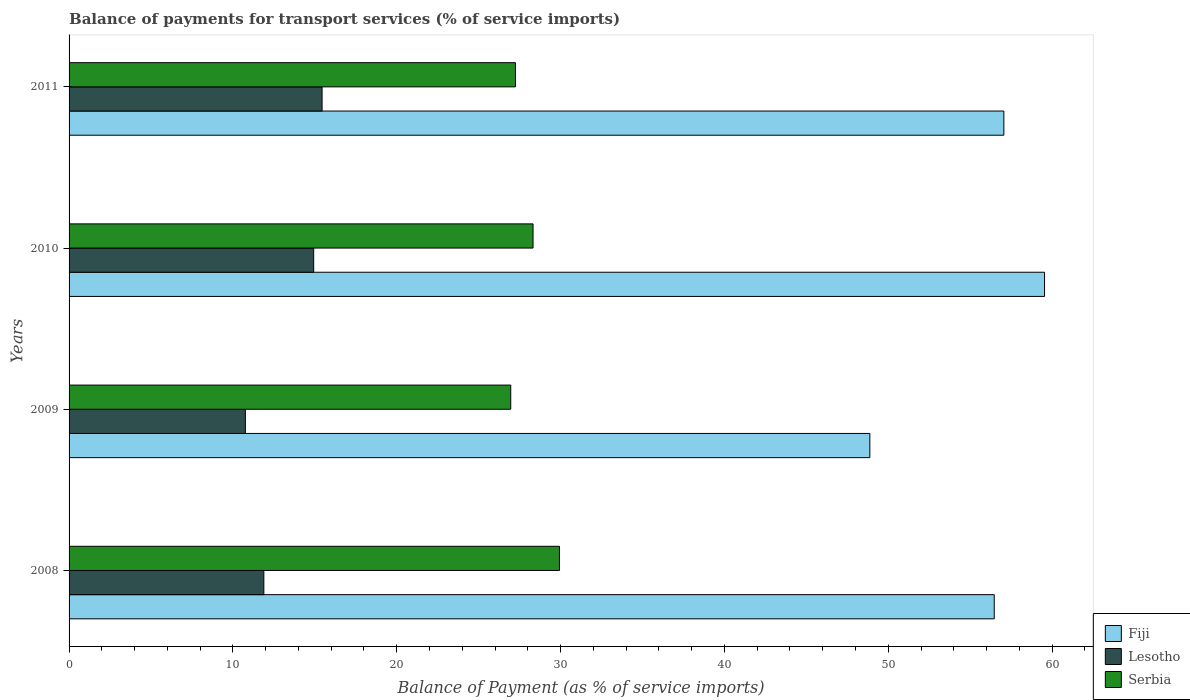Are the number of bars on each tick of the Y-axis equal?
Your response must be concise. Yes. What is the label of the 4th group of bars from the top?
Offer a very short reply. 2008. What is the balance of payments for transport services in Fiji in 2010?
Keep it short and to the point. 59.54. Across all years, what is the maximum balance of payments for transport services in Lesotho?
Give a very brief answer. 15.44. Across all years, what is the minimum balance of payments for transport services in Lesotho?
Offer a very short reply. 10.76. In which year was the balance of payments for transport services in Serbia maximum?
Provide a short and direct response. 2008. What is the total balance of payments for transport services in Fiji in the graph?
Your answer should be very brief. 221.94. What is the difference between the balance of payments for transport services in Serbia in 2010 and that in 2011?
Provide a short and direct response. 1.07. What is the difference between the balance of payments for transport services in Serbia in 2010 and the balance of payments for transport services in Lesotho in 2009?
Ensure brevity in your answer.  17.56. What is the average balance of payments for transport services in Fiji per year?
Your response must be concise. 55.48. In the year 2010, what is the difference between the balance of payments for transport services in Fiji and balance of payments for transport services in Lesotho?
Your response must be concise. 44.61. In how many years, is the balance of payments for transport services in Serbia greater than 30 %?
Offer a terse response. 0. What is the ratio of the balance of payments for transport services in Serbia in 2010 to that in 2011?
Offer a terse response. 1.04. Is the difference between the balance of payments for transport services in Fiji in 2008 and 2011 greater than the difference between the balance of payments for transport services in Lesotho in 2008 and 2011?
Ensure brevity in your answer.  Yes. What is the difference between the highest and the second highest balance of payments for transport services in Serbia?
Make the answer very short. 1.61. What is the difference between the highest and the lowest balance of payments for transport services in Fiji?
Provide a short and direct response. 10.66. In how many years, is the balance of payments for transport services in Lesotho greater than the average balance of payments for transport services in Lesotho taken over all years?
Your response must be concise. 2. Is the sum of the balance of payments for transport services in Fiji in 2008 and 2011 greater than the maximum balance of payments for transport services in Lesotho across all years?
Offer a terse response. Yes. What does the 1st bar from the top in 2009 represents?
Your response must be concise. Serbia. What does the 3rd bar from the bottom in 2011 represents?
Make the answer very short. Serbia. Is it the case that in every year, the sum of the balance of payments for transport services in Serbia and balance of payments for transport services in Fiji is greater than the balance of payments for transport services in Lesotho?
Ensure brevity in your answer.  Yes. Are all the bars in the graph horizontal?
Keep it short and to the point. Yes. How many years are there in the graph?
Offer a terse response. 4. Are the values on the major ticks of X-axis written in scientific E-notation?
Ensure brevity in your answer.  No. Does the graph contain grids?
Offer a very short reply. No. Where does the legend appear in the graph?
Provide a short and direct response. Bottom right. What is the title of the graph?
Offer a terse response. Balance of payments for transport services (% of service imports). What is the label or title of the X-axis?
Ensure brevity in your answer.  Balance of Payment (as % of service imports). What is the label or title of the Y-axis?
Provide a short and direct response. Years. What is the Balance of Payment (as % of service imports) of Fiji in 2008?
Give a very brief answer. 56.47. What is the Balance of Payment (as % of service imports) of Lesotho in 2008?
Provide a succinct answer. 11.89. What is the Balance of Payment (as % of service imports) in Serbia in 2008?
Your response must be concise. 29.93. What is the Balance of Payment (as % of service imports) of Fiji in 2009?
Offer a terse response. 48.87. What is the Balance of Payment (as % of service imports) in Lesotho in 2009?
Offer a very short reply. 10.76. What is the Balance of Payment (as % of service imports) of Serbia in 2009?
Give a very brief answer. 26.96. What is the Balance of Payment (as % of service imports) in Fiji in 2010?
Your response must be concise. 59.54. What is the Balance of Payment (as % of service imports) in Lesotho in 2010?
Provide a short and direct response. 14.93. What is the Balance of Payment (as % of service imports) of Serbia in 2010?
Your response must be concise. 28.32. What is the Balance of Payment (as % of service imports) in Fiji in 2011?
Make the answer very short. 57.06. What is the Balance of Payment (as % of service imports) of Lesotho in 2011?
Your answer should be compact. 15.44. What is the Balance of Payment (as % of service imports) in Serbia in 2011?
Your response must be concise. 27.25. Across all years, what is the maximum Balance of Payment (as % of service imports) in Fiji?
Make the answer very short. 59.54. Across all years, what is the maximum Balance of Payment (as % of service imports) in Lesotho?
Your answer should be compact. 15.44. Across all years, what is the maximum Balance of Payment (as % of service imports) in Serbia?
Provide a short and direct response. 29.93. Across all years, what is the minimum Balance of Payment (as % of service imports) in Fiji?
Keep it short and to the point. 48.87. Across all years, what is the minimum Balance of Payment (as % of service imports) in Lesotho?
Make the answer very short. 10.76. Across all years, what is the minimum Balance of Payment (as % of service imports) of Serbia?
Make the answer very short. 26.96. What is the total Balance of Payment (as % of service imports) in Fiji in the graph?
Give a very brief answer. 221.94. What is the total Balance of Payment (as % of service imports) of Lesotho in the graph?
Make the answer very short. 53.02. What is the total Balance of Payment (as % of service imports) of Serbia in the graph?
Make the answer very short. 112.45. What is the difference between the Balance of Payment (as % of service imports) in Fiji in 2008 and that in 2009?
Ensure brevity in your answer.  7.59. What is the difference between the Balance of Payment (as % of service imports) in Lesotho in 2008 and that in 2009?
Your answer should be compact. 1.13. What is the difference between the Balance of Payment (as % of service imports) of Serbia in 2008 and that in 2009?
Your answer should be very brief. 2.98. What is the difference between the Balance of Payment (as % of service imports) in Fiji in 2008 and that in 2010?
Offer a very short reply. -3.07. What is the difference between the Balance of Payment (as % of service imports) of Lesotho in 2008 and that in 2010?
Your answer should be compact. -3.04. What is the difference between the Balance of Payment (as % of service imports) of Serbia in 2008 and that in 2010?
Give a very brief answer. 1.61. What is the difference between the Balance of Payment (as % of service imports) of Fiji in 2008 and that in 2011?
Provide a short and direct response. -0.59. What is the difference between the Balance of Payment (as % of service imports) of Lesotho in 2008 and that in 2011?
Your answer should be compact. -3.55. What is the difference between the Balance of Payment (as % of service imports) of Serbia in 2008 and that in 2011?
Keep it short and to the point. 2.69. What is the difference between the Balance of Payment (as % of service imports) of Fiji in 2009 and that in 2010?
Offer a terse response. -10.66. What is the difference between the Balance of Payment (as % of service imports) of Lesotho in 2009 and that in 2010?
Offer a terse response. -4.17. What is the difference between the Balance of Payment (as % of service imports) in Serbia in 2009 and that in 2010?
Give a very brief answer. -1.36. What is the difference between the Balance of Payment (as % of service imports) of Fiji in 2009 and that in 2011?
Your answer should be very brief. -8.18. What is the difference between the Balance of Payment (as % of service imports) in Lesotho in 2009 and that in 2011?
Your answer should be very brief. -4.68. What is the difference between the Balance of Payment (as % of service imports) of Serbia in 2009 and that in 2011?
Your answer should be compact. -0.29. What is the difference between the Balance of Payment (as % of service imports) of Fiji in 2010 and that in 2011?
Provide a succinct answer. 2.48. What is the difference between the Balance of Payment (as % of service imports) in Lesotho in 2010 and that in 2011?
Give a very brief answer. -0.51. What is the difference between the Balance of Payment (as % of service imports) in Serbia in 2010 and that in 2011?
Your response must be concise. 1.07. What is the difference between the Balance of Payment (as % of service imports) of Fiji in 2008 and the Balance of Payment (as % of service imports) of Lesotho in 2009?
Offer a terse response. 45.71. What is the difference between the Balance of Payment (as % of service imports) in Fiji in 2008 and the Balance of Payment (as % of service imports) in Serbia in 2009?
Offer a very short reply. 29.51. What is the difference between the Balance of Payment (as % of service imports) in Lesotho in 2008 and the Balance of Payment (as % of service imports) in Serbia in 2009?
Give a very brief answer. -15.07. What is the difference between the Balance of Payment (as % of service imports) in Fiji in 2008 and the Balance of Payment (as % of service imports) in Lesotho in 2010?
Your answer should be very brief. 41.54. What is the difference between the Balance of Payment (as % of service imports) in Fiji in 2008 and the Balance of Payment (as % of service imports) in Serbia in 2010?
Make the answer very short. 28.15. What is the difference between the Balance of Payment (as % of service imports) of Lesotho in 2008 and the Balance of Payment (as % of service imports) of Serbia in 2010?
Your answer should be compact. -16.43. What is the difference between the Balance of Payment (as % of service imports) in Fiji in 2008 and the Balance of Payment (as % of service imports) in Lesotho in 2011?
Your response must be concise. 41.03. What is the difference between the Balance of Payment (as % of service imports) of Fiji in 2008 and the Balance of Payment (as % of service imports) of Serbia in 2011?
Keep it short and to the point. 29.22. What is the difference between the Balance of Payment (as % of service imports) in Lesotho in 2008 and the Balance of Payment (as % of service imports) in Serbia in 2011?
Offer a terse response. -15.36. What is the difference between the Balance of Payment (as % of service imports) of Fiji in 2009 and the Balance of Payment (as % of service imports) of Lesotho in 2010?
Make the answer very short. 33.95. What is the difference between the Balance of Payment (as % of service imports) of Fiji in 2009 and the Balance of Payment (as % of service imports) of Serbia in 2010?
Provide a succinct answer. 20.56. What is the difference between the Balance of Payment (as % of service imports) in Lesotho in 2009 and the Balance of Payment (as % of service imports) in Serbia in 2010?
Keep it short and to the point. -17.56. What is the difference between the Balance of Payment (as % of service imports) of Fiji in 2009 and the Balance of Payment (as % of service imports) of Lesotho in 2011?
Provide a succinct answer. 33.43. What is the difference between the Balance of Payment (as % of service imports) in Fiji in 2009 and the Balance of Payment (as % of service imports) in Serbia in 2011?
Your answer should be very brief. 21.63. What is the difference between the Balance of Payment (as % of service imports) of Lesotho in 2009 and the Balance of Payment (as % of service imports) of Serbia in 2011?
Provide a short and direct response. -16.48. What is the difference between the Balance of Payment (as % of service imports) in Fiji in 2010 and the Balance of Payment (as % of service imports) in Lesotho in 2011?
Your response must be concise. 44.1. What is the difference between the Balance of Payment (as % of service imports) in Fiji in 2010 and the Balance of Payment (as % of service imports) in Serbia in 2011?
Give a very brief answer. 32.29. What is the difference between the Balance of Payment (as % of service imports) in Lesotho in 2010 and the Balance of Payment (as % of service imports) in Serbia in 2011?
Provide a succinct answer. -12.32. What is the average Balance of Payment (as % of service imports) of Fiji per year?
Your answer should be very brief. 55.48. What is the average Balance of Payment (as % of service imports) of Lesotho per year?
Your response must be concise. 13.26. What is the average Balance of Payment (as % of service imports) in Serbia per year?
Your response must be concise. 28.11. In the year 2008, what is the difference between the Balance of Payment (as % of service imports) in Fiji and Balance of Payment (as % of service imports) in Lesotho?
Provide a succinct answer. 44.58. In the year 2008, what is the difference between the Balance of Payment (as % of service imports) of Fiji and Balance of Payment (as % of service imports) of Serbia?
Make the answer very short. 26.54. In the year 2008, what is the difference between the Balance of Payment (as % of service imports) of Lesotho and Balance of Payment (as % of service imports) of Serbia?
Give a very brief answer. -18.04. In the year 2009, what is the difference between the Balance of Payment (as % of service imports) in Fiji and Balance of Payment (as % of service imports) in Lesotho?
Your answer should be compact. 38.11. In the year 2009, what is the difference between the Balance of Payment (as % of service imports) of Fiji and Balance of Payment (as % of service imports) of Serbia?
Keep it short and to the point. 21.92. In the year 2009, what is the difference between the Balance of Payment (as % of service imports) in Lesotho and Balance of Payment (as % of service imports) in Serbia?
Offer a terse response. -16.2. In the year 2010, what is the difference between the Balance of Payment (as % of service imports) in Fiji and Balance of Payment (as % of service imports) in Lesotho?
Offer a very short reply. 44.61. In the year 2010, what is the difference between the Balance of Payment (as % of service imports) of Fiji and Balance of Payment (as % of service imports) of Serbia?
Your response must be concise. 31.22. In the year 2010, what is the difference between the Balance of Payment (as % of service imports) of Lesotho and Balance of Payment (as % of service imports) of Serbia?
Offer a terse response. -13.39. In the year 2011, what is the difference between the Balance of Payment (as % of service imports) of Fiji and Balance of Payment (as % of service imports) of Lesotho?
Your answer should be very brief. 41.61. In the year 2011, what is the difference between the Balance of Payment (as % of service imports) of Fiji and Balance of Payment (as % of service imports) of Serbia?
Your response must be concise. 29.81. In the year 2011, what is the difference between the Balance of Payment (as % of service imports) in Lesotho and Balance of Payment (as % of service imports) in Serbia?
Provide a succinct answer. -11.8. What is the ratio of the Balance of Payment (as % of service imports) of Fiji in 2008 to that in 2009?
Give a very brief answer. 1.16. What is the ratio of the Balance of Payment (as % of service imports) in Lesotho in 2008 to that in 2009?
Keep it short and to the point. 1.1. What is the ratio of the Balance of Payment (as % of service imports) in Serbia in 2008 to that in 2009?
Your answer should be compact. 1.11. What is the ratio of the Balance of Payment (as % of service imports) of Fiji in 2008 to that in 2010?
Give a very brief answer. 0.95. What is the ratio of the Balance of Payment (as % of service imports) of Lesotho in 2008 to that in 2010?
Offer a terse response. 0.8. What is the ratio of the Balance of Payment (as % of service imports) in Serbia in 2008 to that in 2010?
Ensure brevity in your answer.  1.06. What is the ratio of the Balance of Payment (as % of service imports) in Fiji in 2008 to that in 2011?
Your answer should be compact. 0.99. What is the ratio of the Balance of Payment (as % of service imports) in Lesotho in 2008 to that in 2011?
Make the answer very short. 0.77. What is the ratio of the Balance of Payment (as % of service imports) of Serbia in 2008 to that in 2011?
Give a very brief answer. 1.1. What is the ratio of the Balance of Payment (as % of service imports) in Fiji in 2009 to that in 2010?
Provide a succinct answer. 0.82. What is the ratio of the Balance of Payment (as % of service imports) in Lesotho in 2009 to that in 2010?
Offer a terse response. 0.72. What is the ratio of the Balance of Payment (as % of service imports) of Serbia in 2009 to that in 2010?
Provide a succinct answer. 0.95. What is the ratio of the Balance of Payment (as % of service imports) of Fiji in 2009 to that in 2011?
Ensure brevity in your answer.  0.86. What is the ratio of the Balance of Payment (as % of service imports) in Lesotho in 2009 to that in 2011?
Your answer should be compact. 0.7. What is the ratio of the Balance of Payment (as % of service imports) of Serbia in 2009 to that in 2011?
Provide a short and direct response. 0.99. What is the ratio of the Balance of Payment (as % of service imports) of Fiji in 2010 to that in 2011?
Give a very brief answer. 1.04. What is the ratio of the Balance of Payment (as % of service imports) in Lesotho in 2010 to that in 2011?
Your answer should be compact. 0.97. What is the ratio of the Balance of Payment (as % of service imports) of Serbia in 2010 to that in 2011?
Your answer should be very brief. 1.04. What is the difference between the highest and the second highest Balance of Payment (as % of service imports) in Fiji?
Your answer should be compact. 2.48. What is the difference between the highest and the second highest Balance of Payment (as % of service imports) in Lesotho?
Ensure brevity in your answer.  0.51. What is the difference between the highest and the second highest Balance of Payment (as % of service imports) in Serbia?
Offer a very short reply. 1.61. What is the difference between the highest and the lowest Balance of Payment (as % of service imports) of Fiji?
Keep it short and to the point. 10.66. What is the difference between the highest and the lowest Balance of Payment (as % of service imports) of Lesotho?
Offer a very short reply. 4.68. What is the difference between the highest and the lowest Balance of Payment (as % of service imports) of Serbia?
Offer a terse response. 2.98. 